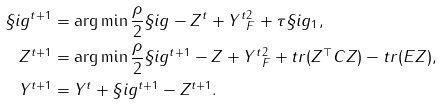Convert formula to latex. <formula><loc_0><loc_0><loc_500><loc_500>\S i g ^ { t + 1 } & = \arg \min \frac { \rho } { 2 } \| \S i g - Z ^ { t } + Y ^ { t } \| _ { F } ^ { 2 } + \tau \| \S i g \| _ { 1 } , \\ Z ^ { t + 1 } & = \arg \min \frac { \rho } { 2 } \| \S i g ^ { t + 1 } - Z + Y ^ { t } \| _ { F } ^ { 2 } + t r ( Z ^ { \top } C Z ) - t r ( E Z ) , \\ Y ^ { t + 1 } & = Y ^ { t } + \S i g ^ { t + 1 } - Z ^ { t + 1 } .</formula> 